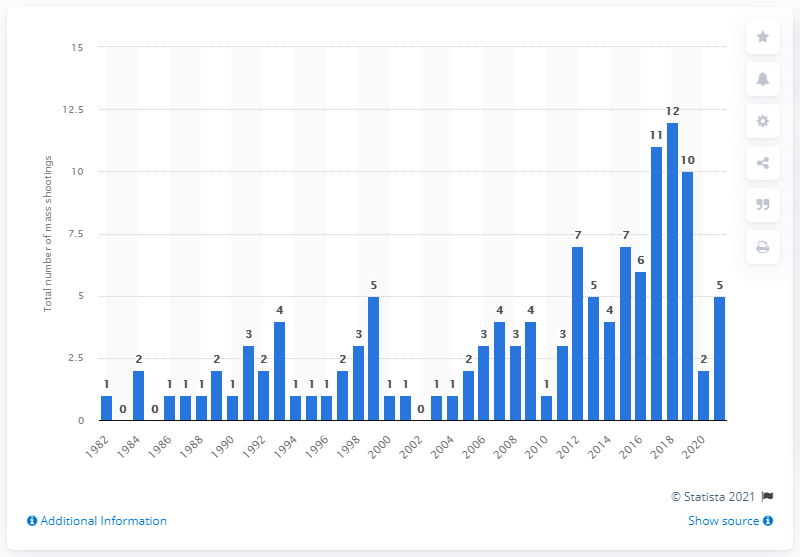Give some essential details in this illustration. There were 12 mass shootings in 2018. 